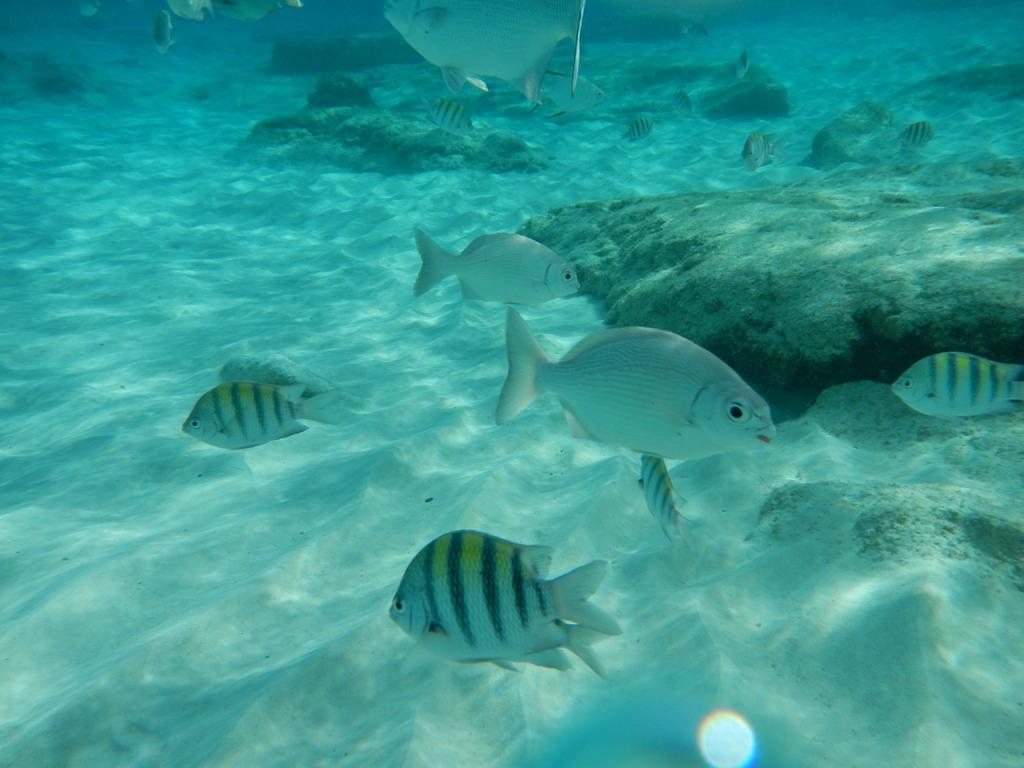Can you describe this image briefly? In this image we can see fishes, stones and sand are under the water. 